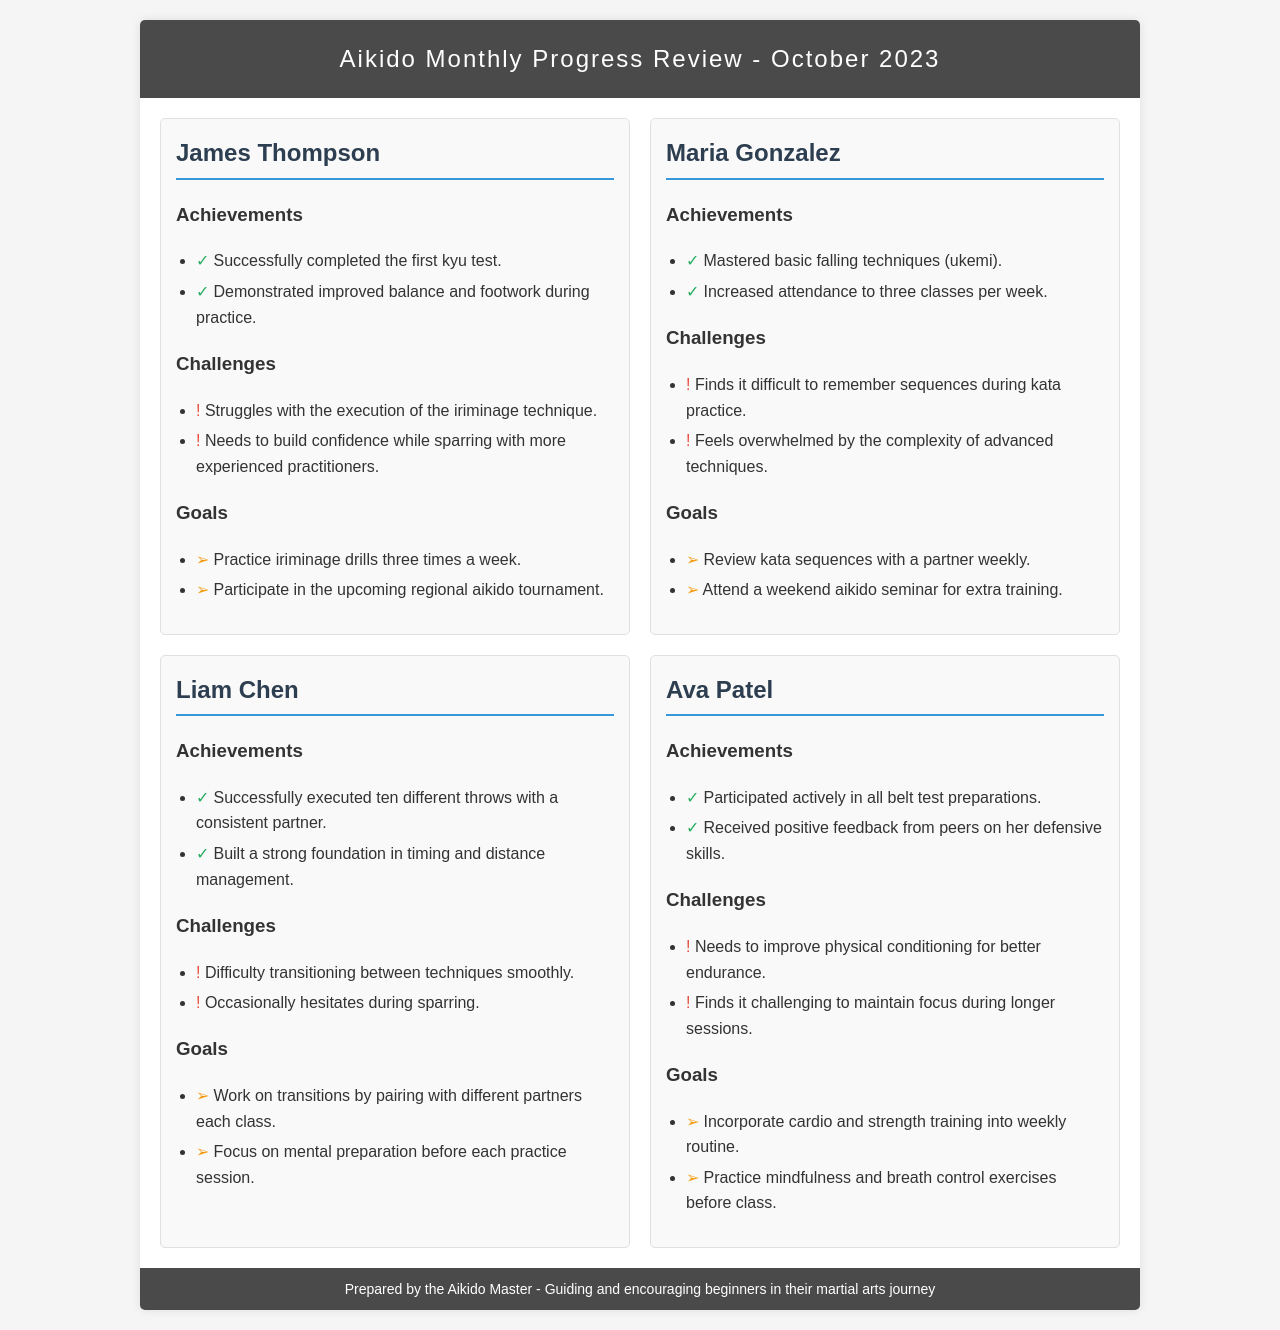What is the title of the document? The title is stated within the HTML code and describes the content, which is Aikido Monthly Progress Review for October 2023.
Answer: Aikido Monthly Progress Review - October 2023 How many students are reviewed in the document? The document contains four student reviews, each presented in a structured card format.
Answer: Four What achievement did James Thompson complete? The document states that James successfully completed the first kyu test, which is an achievement highlighted in his section.
Answer: Successfully completed the first kyu test What is Maria Gonzalez's first listed challenge? The first challenge listed for Maria is about her difficulty remembering sequences during kata practice.
Answer: Finds it difficult to remember sequences during kata practice How many times a week does James aim to practice iriminage drills? The goals section for James specifies that he aims to practice iriminage drills three times a week.
Answer: Three times a week What technique does Liam Chen have difficulty with? According to the challenges section, Liam has difficulty transitioning between techniques smoothly.
Answer: Transitioning between techniques smoothly What type of training does Ava Patel plan to incorporate into her routine? Ava's goals specify incorporating cardio and strength training into her weekly routine to improve endurance.
Answer: Cardio and strength training What positive feedback did Ava receive from peers? The document notes that Ava received positive feedback specifically on her defensive skills during practice.
Answer: Positive feedback on her defensive skills 